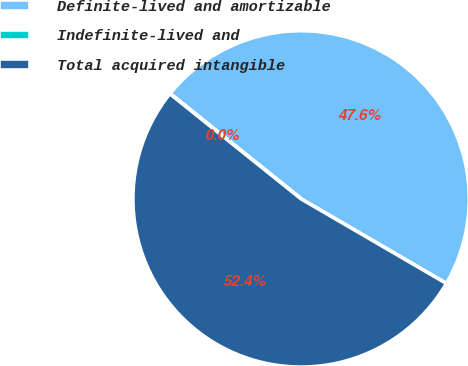Convert chart to OTSL. <chart><loc_0><loc_0><loc_500><loc_500><pie_chart><fcel>Definite-lived and amortizable<fcel>Indefinite-lived and<fcel>Total acquired intangible<nl><fcel>47.61%<fcel>0.03%<fcel>52.36%<nl></chart> 